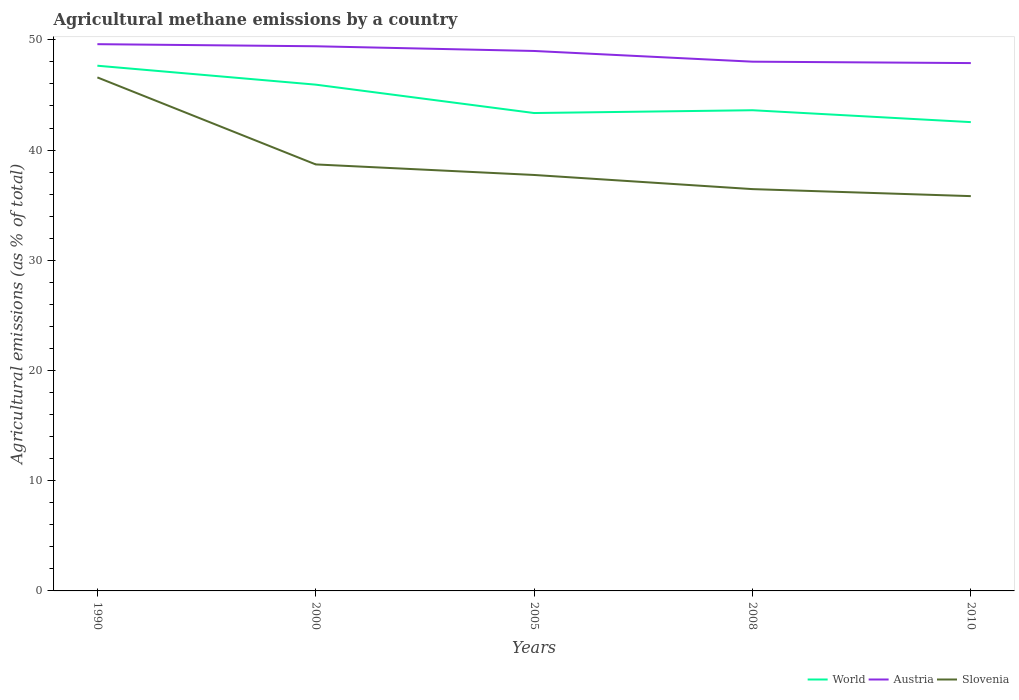Is the number of lines equal to the number of legend labels?
Your answer should be very brief. Yes. Across all years, what is the maximum amount of agricultural methane emitted in World?
Provide a short and direct response. 42.53. What is the total amount of agricultural methane emitted in Austria in the graph?
Offer a terse response. 0.13. What is the difference between the highest and the second highest amount of agricultural methane emitted in Slovenia?
Provide a succinct answer. 10.77. What is the difference between the highest and the lowest amount of agricultural methane emitted in Slovenia?
Keep it short and to the point. 1. Is the amount of agricultural methane emitted in Slovenia strictly greater than the amount of agricultural methane emitted in Austria over the years?
Ensure brevity in your answer.  Yes. Are the values on the major ticks of Y-axis written in scientific E-notation?
Give a very brief answer. No. Does the graph contain any zero values?
Your answer should be very brief. No. How are the legend labels stacked?
Your answer should be very brief. Horizontal. What is the title of the graph?
Keep it short and to the point. Agricultural methane emissions by a country. Does "Belize" appear as one of the legend labels in the graph?
Your response must be concise. No. What is the label or title of the Y-axis?
Provide a succinct answer. Agricultural emissions (as % of total). What is the Agricultural emissions (as % of total) of World in 1990?
Offer a very short reply. 47.65. What is the Agricultural emissions (as % of total) of Austria in 1990?
Your answer should be very brief. 49.61. What is the Agricultural emissions (as % of total) of Slovenia in 1990?
Ensure brevity in your answer.  46.59. What is the Agricultural emissions (as % of total) of World in 2000?
Provide a short and direct response. 45.93. What is the Agricultural emissions (as % of total) of Austria in 2000?
Make the answer very short. 49.42. What is the Agricultural emissions (as % of total) in Slovenia in 2000?
Your response must be concise. 38.7. What is the Agricultural emissions (as % of total) of World in 2005?
Offer a terse response. 43.36. What is the Agricultural emissions (as % of total) in Austria in 2005?
Make the answer very short. 48.99. What is the Agricultural emissions (as % of total) of Slovenia in 2005?
Ensure brevity in your answer.  37.74. What is the Agricultural emissions (as % of total) of World in 2008?
Offer a terse response. 43.61. What is the Agricultural emissions (as % of total) in Austria in 2008?
Ensure brevity in your answer.  48.02. What is the Agricultural emissions (as % of total) of Slovenia in 2008?
Provide a short and direct response. 36.46. What is the Agricultural emissions (as % of total) in World in 2010?
Ensure brevity in your answer.  42.53. What is the Agricultural emissions (as % of total) in Austria in 2010?
Offer a terse response. 47.89. What is the Agricultural emissions (as % of total) of Slovenia in 2010?
Ensure brevity in your answer.  35.82. Across all years, what is the maximum Agricultural emissions (as % of total) of World?
Make the answer very short. 47.65. Across all years, what is the maximum Agricultural emissions (as % of total) in Austria?
Your answer should be compact. 49.61. Across all years, what is the maximum Agricultural emissions (as % of total) in Slovenia?
Keep it short and to the point. 46.59. Across all years, what is the minimum Agricultural emissions (as % of total) in World?
Offer a very short reply. 42.53. Across all years, what is the minimum Agricultural emissions (as % of total) of Austria?
Offer a terse response. 47.89. Across all years, what is the minimum Agricultural emissions (as % of total) in Slovenia?
Give a very brief answer. 35.82. What is the total Agricultural emissions (as % of total) in World in the graph?
Ensure brevity in your answer.  223.09. What is the total Agricultural emissions (as % of total) of Austria in the graph?
Your response must be concise. 243.92. What is the total Agricultural emissions (as % of total) in Slovenia in the graph?
Provide a short and direct response. 195.3. What is the difference between the Agricultural emissions (as % of total) in World in 1990 and that in 2000?
Provide a succinct answer. 1.72. What is the difference between the Agricultural emissions (as % of total) of Austria in 1990 and that in 2000?
Your response must be concise. 0.19. What is the difference between the Agricultural emissions (as % of total) in Slovenia in 1990 and that in 2000?
Ensure brevity in your answer.  7.89. What is the difference between the Agricultural emissions (as % of total) in World in 1990 and that in 2005?
Offer a very short reply. 4.29. What is the difference between the Agricultural emissions (as % of total) in Austria in 1990 and that in 2005?
Provide a succinct answer. 0.62. What is the difference between the Agricultural emissions (as % of total) of Slovenia in 1990 and that in 2005?
Ensure brevity in your answer.  8.85. What is the difference between the Agricultural emissions (as % of total) of World in 1990 and that in 2008?
Offer a very short reply. 4.04. What is the difference between the Agricultural emissions (as % of total) of Austria in 1990 and that in 2008?
Offer a terse response. 1.59. What is the difference between the Agricultural emissions (as % of total) in Slovenia in 1990 and that in 2008?
Ensure brevity in your answer.  10.13. What is the difference between the Agricultural emissions (as % of total) of World in 1990 and that in 2010?
Provide a succinct answer. 5.12. What is the difference between the Agricultural emissions (as % of total) in Austria in 1990 and that in 2010?
Offer a very short reply. 1.71. What is the difference between the Agricultural emissions (as % of total) of Slovenia in 1990 and that in 2010?
Offer a terse response. 10.77. What is the difference between the Agricultural emissions (as % of total) in World in 2000 and that in 2005?
Provide a short and direct response. 2.58. What is the difference between the Agricultural emissions (as % of total) of Austria in 2000 and that in 2005?
Give a very brief answer. 0.43. What is the difference between the Agricultural emissions (as % of total) of Slovenia in 2000 and that in 2005?
Offer a very short reply. 0.96. What is the difference between the Agricultural emissions (as % of total) of World in 2000 and that in 2008?
Offer a terse response. 2.32. What is the difference between the Agricultural emissions (as % of total) of Austria in 2000 and that in 2008?
Your answer should be compact. 1.4. What is the difference between the Agricultural emissions (as % of total) of Slovenia in 2000 and that in 2008?
Provide a short and direct response. 2.24. What is the difference between the Agricultural emissions (as % of total) of World in 2000 and that in 2010?
Ensure brevity in your answer.  3.4. What is the difference between the Agricultural emissions (as % of total) of Austria in 2000 and that in 2010?
Provide a short and direct response. 1.53. What is the difference between the Agricultural emissions (as % of total) in Slovenia in 2000 and that in 2010?
Your answer should be very brief. 2.88. What is the difference between the Agricultural emissions (as % of total) in World in 2005 and that in 2008?
Keep it short and to the point. -0.25. What is the difference between the Agricultural emissions (as % of total) in Austria in 2005 and that in 2008?
Make the answer very short. 0.97. What is the difference between the Agricultural emissions (as % of total) in Slovenia in 2005 and that in 2008?
Your answer should be compact. 1.28. What is the difference between the Agricultural emissions (as % of total) of World in 2005 and that in 2010?
Keep it short and to the point. 0.82. What is the difference between the Agricultural emissions (as % of total) of Austria in 2005 and that in 2010?
Provide a short and direct response. 1.1. What is the difference between the Agricultural emissions (as % of total) of Slovenia in 2005 and that in 2010?
Your answer should be very brief. 1.92. What is the difference between the Agricultural emissions (as % of total) in World in 2008 and that in 2010?
Keep it short and to the point. 1.08. What is the difference between the Agricultural emissions (as % of total) in Austria in 2008 and that in 2010?
Make the answer very short. 0.13. What is the difference between the Agricultural emissions (as % of total) of Slovenia in 2008 and that in 2010?
Provide a short and direct response. 0.64. What is the difference between the Agricultural emissions (as % of total) of World in 1990 and the Agricultural emissions (as % of total) of Austria in 2000?
Offer a terse response. -1.77. What is the difference between the Agricultural emissions (as % of total) in World in 1990 and the Agricultural emissions (as % of total) in Slovenia in 2000?
Your answer should be very brief. 8.96. What is the difference between the Agricultural emissions (as % of total) of Austria in 1990 and the Agricultural emissions (as % of total) of Slovenia in 2000?
Your response must be concise. 10.91. What is the difference between the Agricultural emissions (as % of total) in World in 1990 and the Agricultural emissions (as % of total) in Austria in 2005?
Offer a very short reply. -1.34. What is the difference between the Agricultural emissions (as % of total) of World in 1990 and the Agricultural emissions (as % of total) of Slovenia in 2005?
Keep it short and to the point. 9.91. What is the difference between the Agricultural emissions (as % of total) of Austria in 1990 and the Agricultural emissions (as % of total) of Slovenia in 2005?
Give a very brief answer. 11.87. What is the difference between the Agricultural emissions (as % of total) in World in 1990 and the Agricultural emissions (as % of total) in Austria in 2008?
Your answer should be very brief. -0.37. What is the difference between the Agricultural emissions (as % of total) in World in 1990 and the Agricultural emissions (as % of total) in Slovenia in 2008?
Your answer should be compact. 11.2. What is the difference between the Agricultural emissions (as % of total) in Austria in 1990 and the Agricultural emissions (as % of total) in Slovenia in 2008?
Your answer should be very brief. 13.15. What is the difference between the Agricultural emissions (as % of total) in World in 1990 and the Agricultural emissions (as % of total) in Austria in 2010?
Keep it short and to the point. -0.24. What is the difference between the Agricultural emissions (as % of total) of World in 1990 and the Agricultural emissions (as % of total) of Slovenia in 2010?
Your response must be concise. 11.83. What is the difference between the Agricultural emissions (as % of total) in Austria in 1990 and the Agricultural emissions (as % of total) in Slovenia in 2010?
Give a very brief answer. 13.79. What is the difference between the Agricultural emissions (as % of total) in World in 2000 and the Agricultural emissions (as % of total) in Austria in 2005?
Your response must be concise. -3.06. What is the difference between the Agricultural emissions (as % of total) in World in 2000 and the Agricultural emissions (as % of total) in Slovenia in 2005?
Keep it short and to the point. 8.19. What is the difference between the Agricultural emissions (as % of total) of Austria in 2000 and the Agricultural emissions (as % of total) of Slovenia in 2005?
Make the answer very short. 11.68. What is the difference between the Agricultural emissions (as % of total) of World in 2000 and the Agricultural emissions (as % of total) of Austria in 2008?
Your answer should be compact. -2.08. What is the difference between the Agricultural emissions (as % of total) of World in 2000 and the Agricultural emissions (as % of total) of Slovenia in 2008?
Ensure brevity in your answer.  9.48. What is the difference between the Agricultural emissions (as % of total) in Austria in 2000 and the Agricultural emissions (as % of total) in Slovenia in 2008?
Your answer should be very brief. 12.96. What is the difference between the Agricultural emissions (as % of total) of World in 2000 and the Agricultural emissions (as % of total) of Austria in 2010?
Your response must be concise. -1.96. What is the difference between the Agricultural emissions (as % of total) in World in 2000 and the Agricultural emissions (as % of total) in Slovenia in 2010?
Your answer should be compact. 10.11. What is the difference between the Agricultural emissions (as % of total) in Austria in 2000 and the Agricultural emissions (as % of total) in Slovenia in 2010?
Offer a terse response. 13.6. What is the difference between the Agricultural emissions (as % of total) of World in 2005 and the Agricultural emissions (as % of total) of Austria in 2008?
Give a very brief answer. -4.66. What is the difference between the Agricultural emissions (as % of total) in World in 2005 and the Agricultural emissions (as % of total) in Slovenia in 2008?
Your answer should be very brief. 6.9. What is the difference between the Agricultural emissions (as % of total) of Austria in 2005 and the Agricultural emissions (as % of total) of Slovenia in 2008?
Offer a very short reply. 12.53. What is the difference between the Agricultural emissions (as % of total) in World in 2005 and the Agricultural emissions (as % of total) in Austria in 2010?
Ensure brevity in your answer.  -4.53. What is the difference between the Agricultural emissions (as % of total) in World in 2005 and the Agricultural emissions (as % of total) in Slovenia in 2010?
Ensure brevity in your answer.  7.54. What is the difference between the Agricultural emissions (as % of total) of Austria in 2005 and the Agricultural emissions (as % of total) of Slovenia in 2010?
Provide a succinct answer. 13.17. What is the difference between the Agricultural emissions (as % of total) of World in 2008 and the Agricultural emissions (as % of total) of Austria in 2010?
Give a very brief answer. -4.28. What is the difference between the Agricultural emissions (as % of total) of World in 2008 and the Agricultural emissions (as % of total) of Slovenia in 2010?
Make the answer very short. 7.79. What is the difference between the Agricultural emissions (as % of total) of Austria in 2008 and the Agricultural emissions (as % of total) of Slovenia in 2010?
Provide a succinct answer. 12.2. What is the average Agricultural emissions (as % of total) in World per year?
Your answer should be very brief. 44.62. What is the average Agricultural emissions (as % of total) in Austria per year?
Your answer should be very brief. 48.78. What is the average Agricultural emissions (as % of total) in Slovenia per year?
Offer a terse response. 39.06. In the year 1990, what is the difference between the Agricultural emissions (as % of total) in World and Agricultural emissions (as % of total) in Austria?
Provide a short and direct response. -1.95. In the year 1990, what is the difference between the Agricultural emissions (as % of total) of World and Agricultural emissions (as % of total) of Slovenia?
Make the answer very short. 1.06. In the year 1990, what is the difference between the Agricultural emissions (as % of total) in Austria and Agricultural emissions (as % of total) in Slovenia?
Offer a terse response. 3.02. In the year 2000, what is the difference between the Agricultural emissions (as % of total) in World and Agricultural emissions (as % of total) in Austria?
Give a very brief answer. -3.48. In the year 2000, what is the difference between the Agricultural emissions (as % of total) in World and Agricultural emissions (as % of total) in Slovenia?
Ensure brevity in your answer.  7.24. In the year 2000, what is the difference between the Agricultural emissions (as % of total) in Austria and Agricultural emissions (as % of total) in Slovenia?
Your answer should be very brief. 10.72. In the year 2005, what is the difference between the Agricultural emissions (as % of total) in World and Agricultural emissions (as % of total) in Austria?
Your answer should be very brief. -5.63. In the year 2005, what is the difference between the Agricultural emissions (as % of total) of World and Agricultural emissions (as % of total) of Slovenia?
Make the answer very short. 5.62. In the year 2005, what is the difference between the Agricultural emissions (as % of total) in Austria and Agricultural emissions (as % of total) in Slovenia?
Provide a short and direct response. 11.25. In the year 2008, what is the difference between the Agricultural emissions (as % of total) in World and Agricultural emissions (as % of total) in Austria?
Your answer should be very brief. -4.41. In the year 2008, what is the difference between the Agricultural emissions (as % of total) in World and Agricultural emissions (as % of total) in Slovenia?
Give a very brief answer. 7.16. In the year 2008, what is the difference between the Agricultural emissions (as % of total) in Austria and Agricultural emissions (as % of total) in Slovenia?
Offer a terse response. 11.56. In the year 2010, what is the difference between the Agricultural emissions (as % of total) in World and Agricultural emissions (as % of total) in Austria?
Your response must be concise. -5.36. In the year 2010, what is the difference between the Agricultural emissions (as % of total) of World and Agricultural emissions (as % of total) of Slovenia?
Offer a terse response. 6.71. In the year 2010, what is the difference between the Agricultural emissions (as % of total) in Austria and Agricultural emissions (as % of total) in Slovenia?
Give a very brief answer. 12.07. What is the ratio of the Agricultural emissions (as % of total) in World in 1990 to that in 2000?
Give a very brief answer. 1.04. What is the ratio of the Agricultural emissions (as % of total) in Austria in 1990 to that in 2000?
Your answer should be compact. 1. What is the ratio of the Agricultural emissions (as % of total) in Slovenia in 1990 to that in 2000?
Ensure brevity in your answer.  1.2. What is the ratio of the Agricultural emissions (as % of total) of World in 1990 to that in 2005?
Keep it short and to the point. 1.1. What is the ratio of the Agricultural emissions (as % of total) in Austria in 1990 to that in 2005?
Offer a terse response. 1.01. What is the ratio of the Agricultural emissions (as % of total) of Slovenia in 1990 to that in 2005?
Ensure brevity in your answer.  1.23. What is the ratio of the Agricultural emissions (as % of total) in World in 1990 to that in 2008?
Your answer should be compact. 1.09. What is the ratio of the Agricultural emissions (as % of total) of Austria in 1990 to that in 2008?
Provide a succinct answer. 1.03. What is the ratio of the Agricultural emissions (as % of total) in Slovenia in 1990 to that in 2008?
Offer a terse response. 1.28. What is the ratio of the Agricultural emissions (as % of total) of World in 1990 to that in 2010?
Provide a succinct answer. 1.12. What is the ratio of the Agricultural emissions (as % of total) of Austria in 1990 to that in 2010?
Make the answer very short. 1.04. What is the ratio of the Agricultural emissions (as % of total) of Slovenia in 1990 to that in 2010?
Provide a succinct answer. 1.3. What is the ratio of the Agricultural emissions (as % of total) in World in 2000 to that in 2005?
Your answer should be very brief. 1.06. What is the ratio of the Agricultural emissions (as % of total) in Austria in 2000 to that in 2005?
Give a very brief answer. 1.01. What is the ratio of the Agricultural emissions (as % of total) of Slovenia in 2000 to that in 2005?
Provide a short and direct response. 1.03. What is the ratio of the Agricultural emissions (as % of total) of World in 2000 to that in 2008?
Offer a very short reply. 1.05. What is the ratio of the Agricultural emissions (as % of total) of Austria in 2000 to that in 2008?
Give a very brief answer. 1.03. What is the ratio of the Agricultural emissions (as % of total) of Slovenia in 2000 to that in 2008?
Provide a short and direct response. 1.06. What is the ratio of the Agricultural emissions (as % of total) of World in 2000 to that in 2010?
Your answer should be very brief. 1.08. What is the ratio of the Agricultural emissions (as % of total) of Austria in 2000 to that in 2010?
Your answer should be very brief. 1.03. What is the ratio of the Agricultural emissions (as % of total) in Slovenia in 2000 to that in 2010?
Offer a terse response. 1.08. What is the ratio of the Agricultural emissions (as % of total) in World in 2005 to that in 2008?
Your answer should be very brief. 0.99. What is the ratio of the Agricultural emissions (as % of total) in Austria in 2005 to that in 2008?
Give a very brief answer. 1.02. What is the ratio of the Agricultural emissions (as % of total) in Slovenia in 2005 to that in 2008?
Offer a terse response. 1.04. What is the ratio of the Agricultural emissions (as % of total) in World in 2005 to that in 2010?
Keep it short and to the point. 1.02. What is the ratio of the Agricultural emissions (as % of total) of Austria in 2005 to that in 2010?
Keep it short and to the point. 1.02. What is the ratio of the Agricultural emissions (as % of total) in Slovenia in 2005 to that in 2010?
Make the answer very short. 1.05. What is the ratio of the Agricultural emissions (as % of total) in World in 2008 to that in 2010?
Your answer should be very brief. 1.03. What is the ratio of the Agricultural emissions (as % of total) of Slovenia in 2008 to that in 2010?
Offer a terse response. 1.02. What is the difference between the highest and the second highest Agricultural emissions (as % of total) of World?
Make the answer very short. 1.72. What is the difference between the highest and the second highest Agricultural emissions (as % of total) of Austria?
Your answer should be compact. 0.19. What is the difference between the highest and the second highest Agricultural emissions (as % of total) of Slovenia?
Make the answer very short. 7.89. What is the difference between the highest and the lowest Agricultural emissions (as % of total) in World?
Your response must be concise. 5.12. What is the difference between the highest and the lowest Agricultural emissions (as % of total) of Austria?
Provide a succinct answer. 1.71. What is the difference between the highest and the lowest Agricultural emissions (as % of total) in Slovenia?
Your answer should be compact. 10.77. 